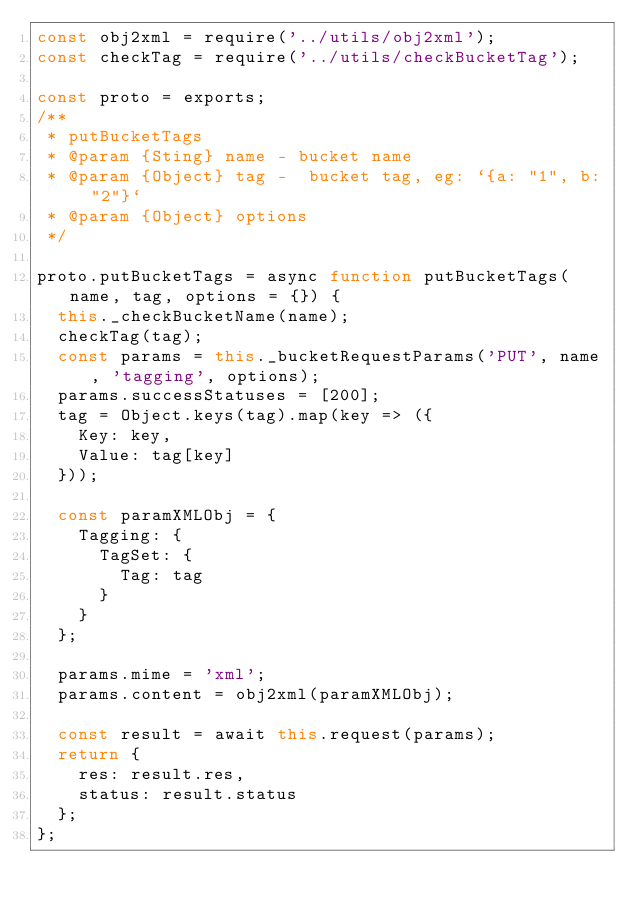Convert code to text. <code><loc_0><loc_0><loc_500><loc_500><_JavaScript_>const obj2xml = require('../utils/obj2xml');
const checkTag = require('../utils/checkBucketTag');

const proto = exports;
/**
 * putBucketTags
 * @param {Sting} name - bucket name
 * @param {Object} tag -  bucket tag, eg: `{a: "1", b: "2"}`
 * @param {Object} options
 */

proto.putBucketTags = async function putBucketTags(name, tag, options = {}) {
  this._checkBucketName(name);
  checkTag(tag);
  const params = this._bucketRequestParams('PUT', name, 'tagging', options);
  params.successStatuses = [200];
  tag = Object.keys(tag).map(key => ({
    Key: key,
    Value: tag[key]
  }));

  const paramXMLObj = {
    Tagging: {
      TagSet: {
        Tag: tag
      }
    }
  };

  params.mime = 'xml';
  params.content = obj2xml(paramXMLObj);

  const result = await this.request(params);
  return {
    res: result.res,
    status: result.status
  };
};
</code> 